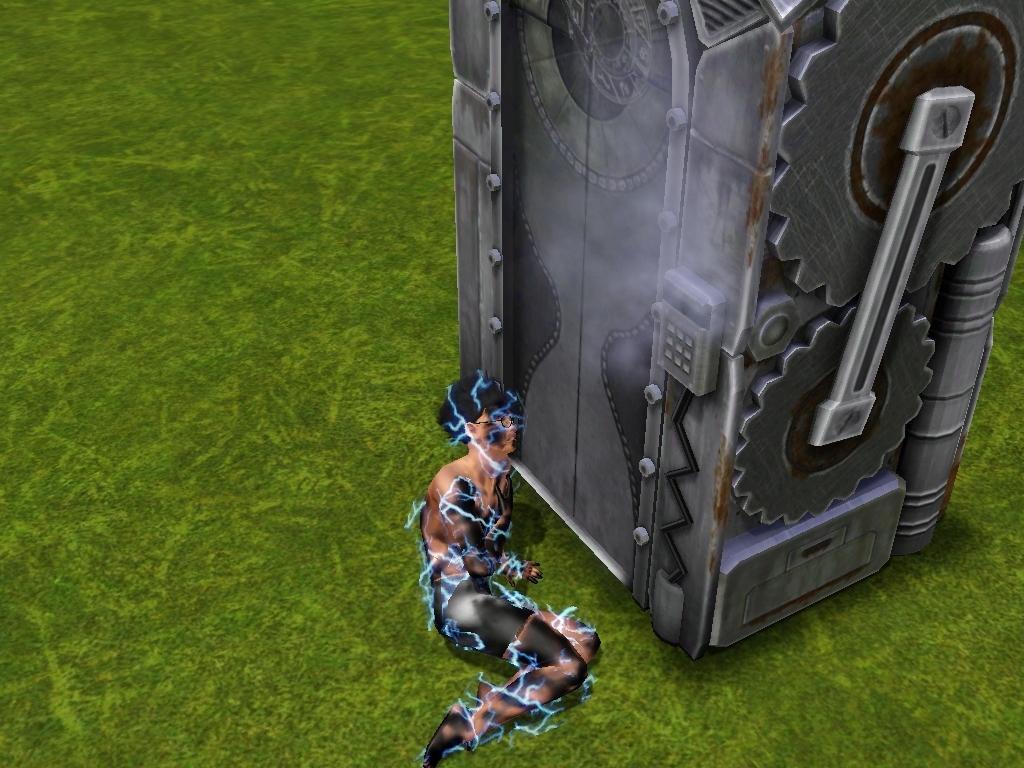Can you describe this image briefly? In the picture we can see a animated picture of a grass surface and a machinery and a person laying on the surface with a shock. 